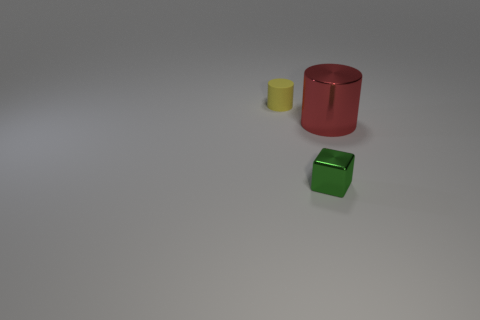Is there any indication of how these objects might be used? The objects seem to be simplistic and could be representative of everyday items, or they might be part of a set for teaching shapes and colors. The cylinders could serve as containers or be purely decorative, while the cube might be a building block, a paperweight, or an educational tool. Without additional context, their exact purpose is left to interpretation, inviting the viewer to imagine their use based on personal experiences and perspectives. 